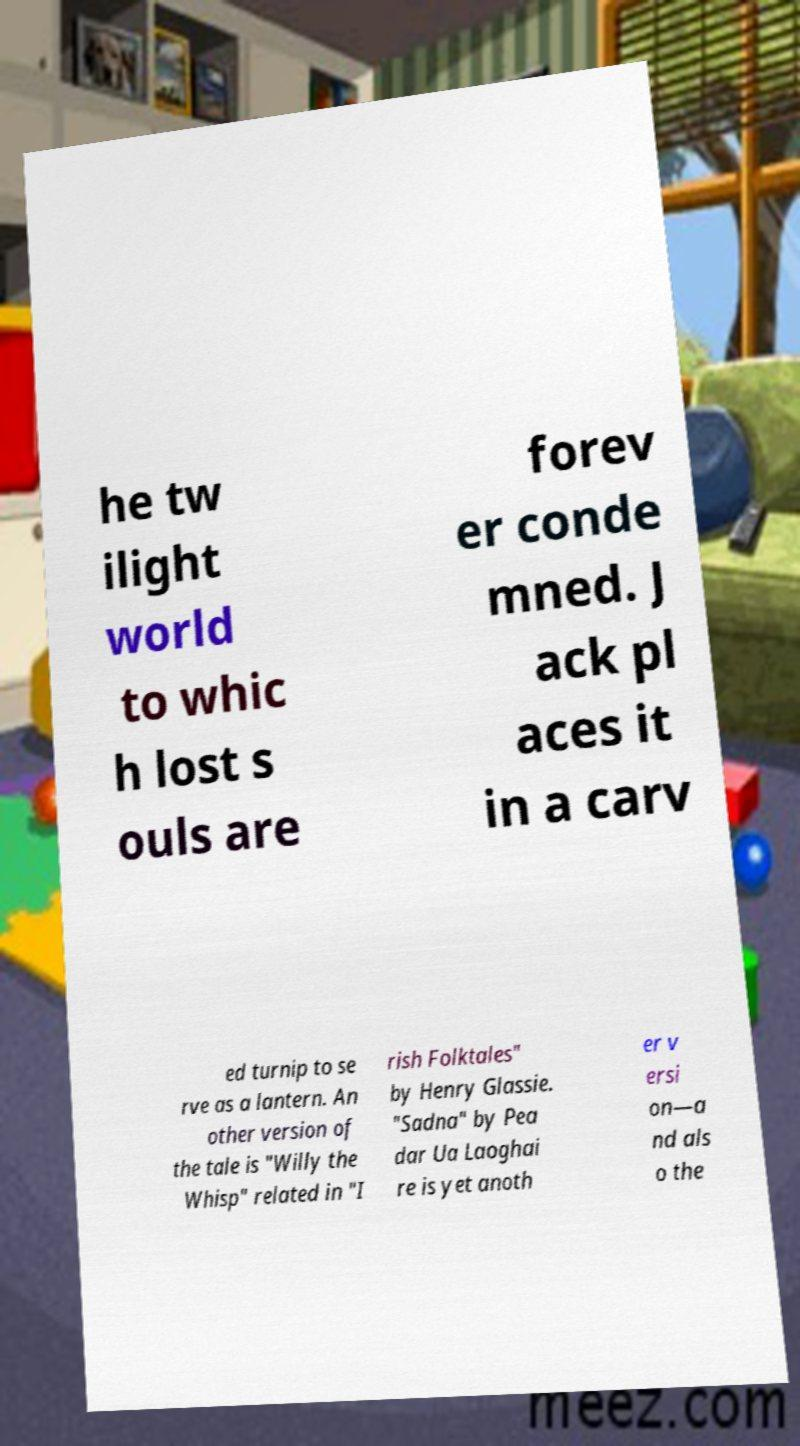There's text embedded in this image that I need extracted. Can you transcribe it verbatim? he tw ilight world to whic h lost s ouls are forev er conde mned. J ack pl aces it in a carv ed turnip to se rve as a lantern. An other version of the tale is "Willy the Whisp" related in "I rish Folktales" by Henry Glassie. "Sadna" by Pea dar Ua Laoghai re is yet anoth er v ersi on—a nd als o the 